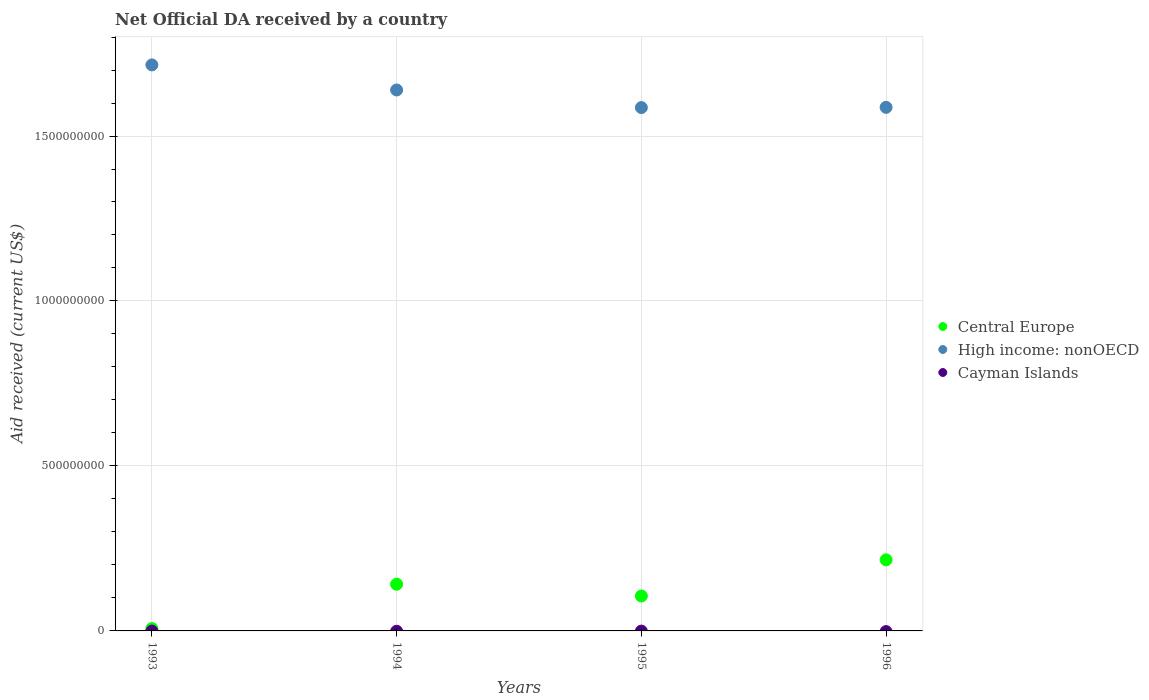How many different coloured dotlines are there?
Keep it short and to the point. 2. Is the number of dotlines equal to the number of legend labels?
Give a very brief answer. No. What is the net official development assistance aid received in High income: nonOECD in 1994?
Make the answer very short. 1.64e+09. Across all years, what is the maximum net official development assistance aid received in High income: nonOECD?
Offer a terse response. 1.72e+09. Across all years, what is the minimum net official development assistance aid received in Central Europe?
Keep it short and to the point. 7.14e+06. What is the total net official development assistance aid received in Central Europe in the graph?
Provide a short and direct response. 4.70e+08. What is the difference between the net official development assistance aid received in High income: nonOECD in 1994 and that in 1996?
Provide a succinct answer. 5.26e+07. What is the difference between the net official development assistance aid received in High income: nonOECD in 1994 and the net official development assistance aid received in Central Europe in 1995?
Your answer should be compact. 1.53e+09. What is the average net official development assistance aid received in High income: nonOECD per year?
Offer a terse response. 1.63e+09. In the year 1993, what is the difference between the net official development assistance aid received in Central Europe and net official development assistance aid received in High income: nonOECD?
Your answer should be very brief. -1.71e+09. In how many years, is the net official development assistance aid received in Central Europe greater than 1200000000 US$?
Offer a terse response. 0. What is the ratio of the net official development assistance aid received in High income: nonOECD in 1993 to that in 1994?
Offer a terse response. 1.05. Is the net official development assistance aid received in High income: nonOECD in 1993 less than that in 1995?
Ensure brevity in your answer.  No. What is the difference between the highest and the second highest net official development assistance aid received in High income: nonOECD?
Your answer should be compact. 7.60e+07. What is the difference between the highest and the lowest net official development assistance aid received in High income: nonOECD?
Offer a terse response. 1.29e+08. In how many years, is the net official development assistance aid received in Central Europe greater than the average net official development assistance aid received in Central Europe taken over all years?
Give a very brief answer. 2. Is the sum of the net official development assistance aid received in Central Europe in 1993 and 1996 greater than the maximum net official development assistance aid received in Cayman Islands across all years?
Provide a short and direct response. Yes. Is it the case that in every year, the sum of the net official development assistance aid received in Central Europe and net official development assistance aid received in High income: nonOECD  is greater than the net official development assistance aid received in Cayman Islands?
Give a very brief answer. Yes. Is the net official development assistance aid received in Cayman Islands strictly greater than the net official development assistance aid received in High income: nonOECD over the years?
Offer a very short reply. No. How many dotlines are there?
Give a very brief answer. 2. How many years are there in the graph?
Ensure brevity in your answer.  4. Are the values on the major ticks of Y-axis written in scientific E-notation?
Keep it short and to the point. No. Does the graph contain any zero values?
Offer a terse response. Yes. How many legend labels are there?
Offer a terse response. 3. How are the legend labels stacked?
Your answer should be very brief. Vertical. What is the title of the graph?
Ensure brevity in your answer.  Net Official DA received by a country. Does "Turks and Caicos Islands" appear as one of the legend labels in the graph?
Offer a very short reply. No. What is the label or title of the Y-axis?
Offer a terse response. Aid received (current US$). What is the Aid received (current US$) of Central Europe in 1993?
Ensure brevity in your answer.  7.14e+06. What is the Aid received (current US$) in High income: nonOECD in 1993?
Offer a very short reply. 1.72e+09. What is the Aid received (current US$) of Central Europe in 1994?
Make the answer very short. 1.42e+08. What is the Aid received (current US$) of High income: nonOECD in 1994?
Your answer should be very brief. 1.64e+09. What is the Aid received (current US$) in Cayman Islands in 1994?
Give a very brief answer. 0. What is the Aid received (current US$) of Central Europe in 1995?
Your response must be concise. 1.06e+08. What is the Aid received (current US$) in High income: nonOECD in 1995?
Keep it short and to the point. 1.59e+09. What is the Aid received (current US$) of Cayman Islands in 1995?
Keep it short and to the point. 0. What is the Aid received (current US$) of Central Europe in 1996?
Make the answer very short. 2.16e+08. What is the Aid received (current US$) of High income: nonOECD in 1996?
Ensure brevity in your answer.  1.59e+09. What is the Aid received (current US$) of Cayman Islands in 1996?
Your answer should be very brief. 0. Across all years, what is the maximum Aid received (current US$) in Central Europe?
Ensure brevity in your answer.  2.16e+08. Across all years, what is the maximum Aid received (current US$) of High income: nonOECD?
Give a very brief answer. 1.72e+09. Across all years, what is the minimum Aid received (current US$) in Central Europe?
Keep it short and to the point. 7.14e+06. Across all years, what is the minimum Aid received (current US$) in High income: nonOECD?
Provide a succinct answer. 1.59e+09. What is the total Aid received (current US$) in Central Europe in the graph?
Offer a very short reply. 4.70e+08. What is the total Aid received (current US$) in High income: nonOECD in the graph?
Provide a succinct answer. 6.53e+09. What is the difference between the Aid received (current US$) in Central Europe in 1993 and that in 1994?
Offer a terse response. -1.34e+08. What is the difference between the Aid received (current US$) of High income: nonOECD in 1993 and that in 1994?
Keep it short and to the point. 7.60e+07. What is the difference between the Aid received (current US$) in Central Europe in 1993 and that in 1995?
Your answer should be compact. -9.87e+07. What is the difference between the Aid received (current US$) of High income: nonOECD in 1993 and that in 1995?
Offer a very short reply. 1.29e+08. What is the difference between the Aid received (current US$) of Central Europe in 1993 and that in 1996?
Offer a terse response. -2.08e+08. What is the difference between the Aid received (current US$) in High income: nonOECD in 1993 and that in 1996?
Offer a very short reply. 1.29e+08. What is the difference between the Aid received (current US$) in Central Europe in 1994 and that in 1995?
Your answer should be compact. 3.57e+07. What is the difference between the Aid received (current US$) in High income: nonOECD in 1994 and that in 1995?
Provide a succinct answer. 5.34e+07. What is the difference between the Aid received (current US$) of Central Europe in 1994 and that in 1996?
Your response must be concise. -7.40e+07. What is the difference between the Aid received (current US$) in High income: nonOECD in 1994 and that in 1996?
Your answer should be very brief. 5.26e+07. What is the difference between the Aid received (current US$) in Central Europe in 1995 and that in 1996?
Provide a short and direct response. -1.10e+08. What is the difference between the Aid received (current US$) of High income: nonOECD in 1995 and that in 1996?
Make the answer very short. -7.30e+05. What is the difference between the Aid received (current US$) in Central Europe in 1993 and the Aid received (current US$) in High income: nonOECD in 1994?
Offer a terse response. -1.63e+09. What is the difference between the Aid received (current US$) in Central Europe in 1993 and the Aid received (current US$) in High income: nonOECD in 1995?
Keep it short and to the point. -1.58e+09. What is the difference between the Aid received (current US$) of Central Europe in 1993 and the Aid received (current US$) of High income: nonOECD in 1996?
Offer a terse response. -1.58e+09. What is the difference between the Aid received (current US$) in Central Europe in 1994 and the Aid received (current US$) in High income: nonOECD in 1995?
Make the answer very short. -1.44e+09. What is the difference between the Aid received (current US$) in Central Europe in 1994 and the Aid received (current US$) in High income: nonOECD in 1996?
Your answer should be very brief. -1.45e+09. What is the difference between the Aid received (current US$) in Central Europe in 1995 and the Aid received (current US$) in High income: nonOECD in 1996?
Provide a succinct answer. -1.48e+09. What is the average Aid received (current US$) of Central Europe per year?
Ensure brevity in your answer.  1.18e+08. What is the average Aid received (current US$) of High income: nonOECD per year?
Offer a very short reply. 1.63e+09. In the year 1993, what is the difference between the Aid received (current US$) in Central Europe and Aid received (current US$) in High income: nonOECD?
Give a very brief answer. -1.71e+09. In the year 1994, what is the difference between the Aid received (current US$) of Central Europe and Aid received (current US$) of High income: nonOECD?
Give a very brief answer. -1.50e+09. In the year 1995, what is the difference between the Aid received (current US$) in Central Europe and Aid received (current US$) in High income: nonOECD?
Offer a very short reply. -1.48e+09. In the year 1996, what is the difference between the Aid received (current US$) of Central Europe and Aid received (current US$) of High income: nonOECD?
Ensure brevity in your answer.  -1.37e+09. What is the ratio of the Aid received (current US$) in Central Europe in 1993 to that in 1994?
Keep it short and to the point. 0.05. What is the ratio of the Aid received (current US$) of High income: nonOECD in 1993 to that in 1994?
Provide a succinct answer. 1.05. What is the ratio of the Aid received (current US$) in Central Europe in 1993 to that in 1995?
Provide a succinct answer. 0.07. What is the ratio of the Aid received (current US$) of High income: nonOECD in 1993 to that in 1995?
Ensure brevity in your answer.  1.08. What is the ratio of the Aid received (current US$) in Central Europe in 1993 to that in 1996?
Give a very brief answer. 0.03. What is the ratio of the Aid received (current US$) of High income: nonOECD in 1993 to that in 1996?
Offer a terse response. 1.08. What is the ratio of the Aid received (current US$) in Central Europe in 1994 to that in 1995?
Your response must be concise. 1.34. What is the ratio of the Aid received (current US$) of High income: nonOECD in 1994 to that in 1995?
Your response must be concise. 1.03. What is the ratio of the Aid received (current US$) of Central Europe in 1994 to that in 1996?
Ensure brevity in your answer.  0.66. What is the ratio of the Aid received (current US$) in High income: nonOECD in 1994 to that in 1996?
Your answer should be very brief. 1.03. What is the ratio of the Aid received (current US$) of Central Europe in 1995 to that in 1996?
Make the answer very short. 0.49. What is the ratio of the Aid received (current US$) of High income: nonOECD in 1995 to that in 1996?
Give a very brief answer. 1. What is the difference between the highest and the second highest Aid received (current US$) in Central Europe?
Your answer should be very brief. 7.40e+07. What is the difference between the highest and the second highest Aid received (current US$) of High income: nonOECD?
Ensure brevity in your answer.  7.60e+07. What is the difference between the highest and the lowest Aid received (current US$) of Central Europe?
Provide a succinct answer. 2.08e+08. What is the difference between the highest and the lowest Aid received (current US$) in High income: nonOECD?
Your answer should be compact. 1.29e+08. 